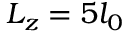<formula> <loc_0><loc_0><loc_500><loc_500>L _ { z } = 5 l _ { 0 }</formula> 